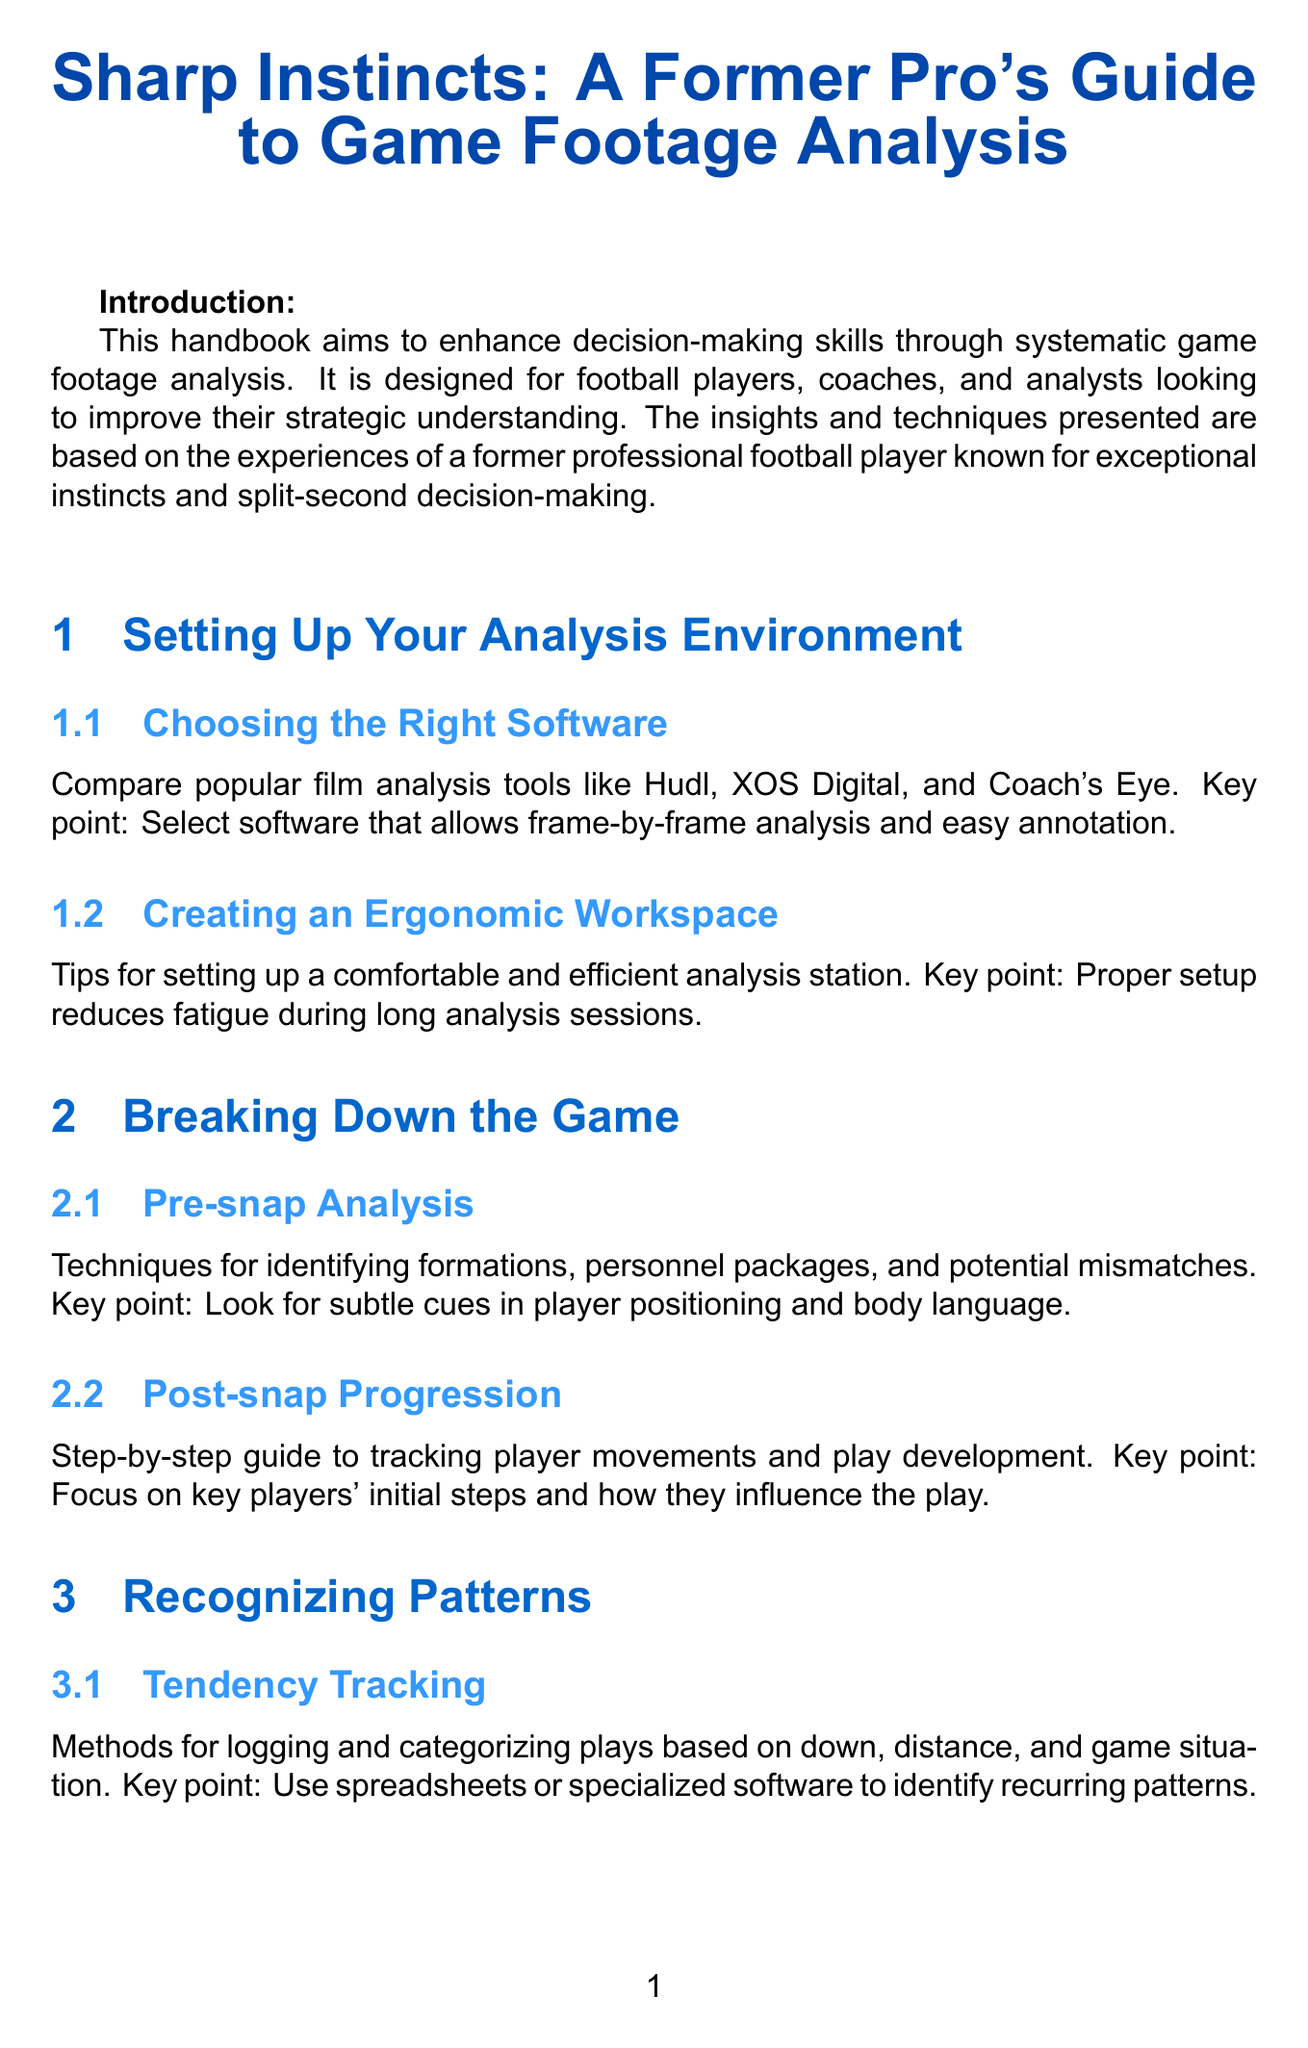what is the title of the handbook? The title of the handbook is stated at the beginning of the document.
Answer: Sharp Instincts: A Former Pro's Guide to Game Footage Analysis who is the target audience for this manual? The target audience is defined in the introduction section.
Answer: Football players, coaches, and analysts what software is recommended for analysis? The recommended software options are listed in the first chapter.
Answer: Hudl, XOS Digital, and Coach's Eye what is a key point of pre-snap analysis? The key point is mentioned in the chapter about breaking down the game.
Answer: Look for subtle cues in player positioning and body language what techniques are suggested for self-assessment? The techniques for self-assessment are covered in the continuous improvement section.
Answer: Be brutally honest in self-assessment to maximize growth how many case studies are included in the handbook? The number of case studies is confirmed at the end of the document before the appendices.
Answer: Two what is the main objective of the handbook? The main objective is outlined in the introduction.
Answer: Enhance decision-making skills through systematic game footage analysis what type of analysis does the chapter on advanced techniques cover? The type of analysis is specified in the title of the respective chapter.
Answer: Opponent-Specific Tendencies and Statistical Integration what is suggested to improve reaction time? The suggestion is found in the section on enhancing decision-making skills.
Answer: Use guided imagery to improve reaction time and decision-making 